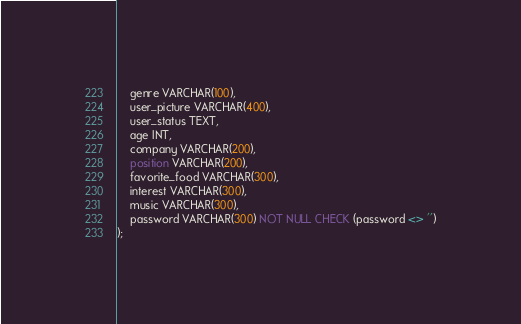Convert code to text. <code><loc_0><loc_0><loc_500><loc_500><_SQL_>    genre VARCHAR(100), 
    user_picture VARCHAR(400),
    user_status TEXT,
    age INT,
    company VARCHAR(200),
    position VARCHAR(200),
    favorite_food VARCHAR(300),
    interest VARCHAR(300),
    music VARCHAR(300),
    password VARCHAR(300) NOT NULL CHECK (password <> '')
);</code> 